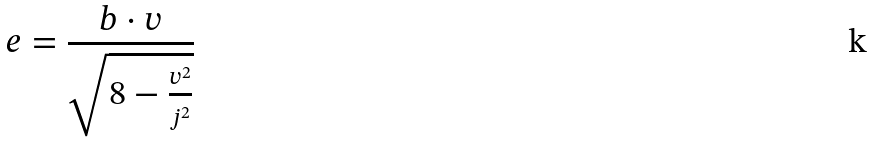<formula> <loc_0><loc_0><loc_500><loc_500>e = \frac { b \cdot v } { \sqrt { 8 - \frac { v ^ { 2 } } { j ^ { 2 } } } }</formula> 